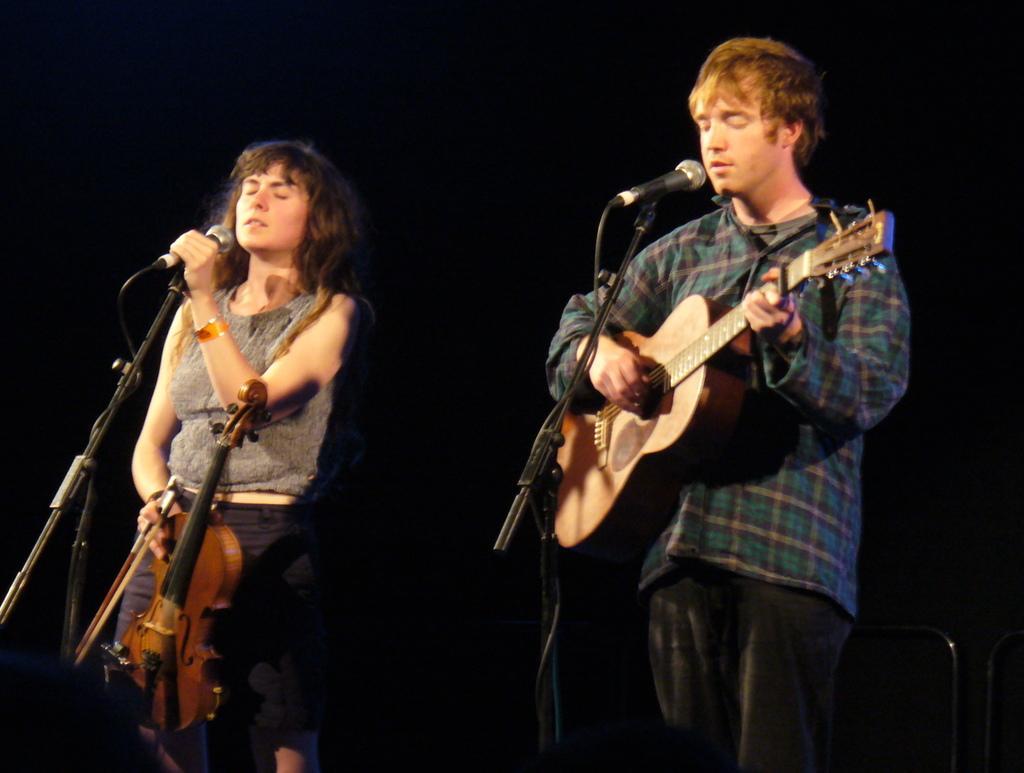Can you describe this image briefly? In this picture we can see a man standing and holding a guitar in his hands, and in front here is the microphone and stand, at beside a woman is standing and holding a violin in her hands. 